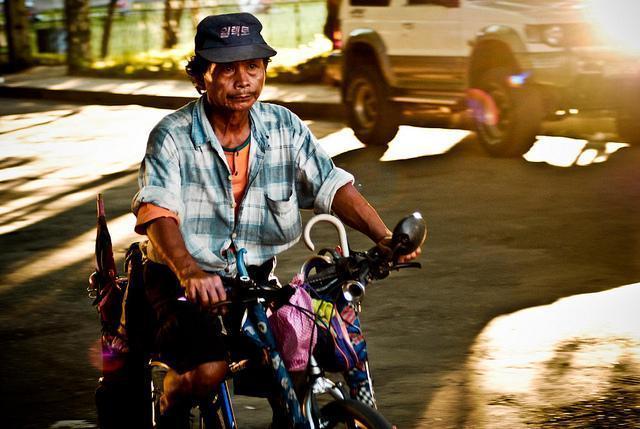How many cars are there?
Give a very brief answer. 1. How many bicycles are in the photo?
Give a very brief answer. 1. How many umbrellas are there?
Give a very brief answer. 3. How many layers of bananas on this tree have been almost totally picked?
Give a very brief answer. 0. 